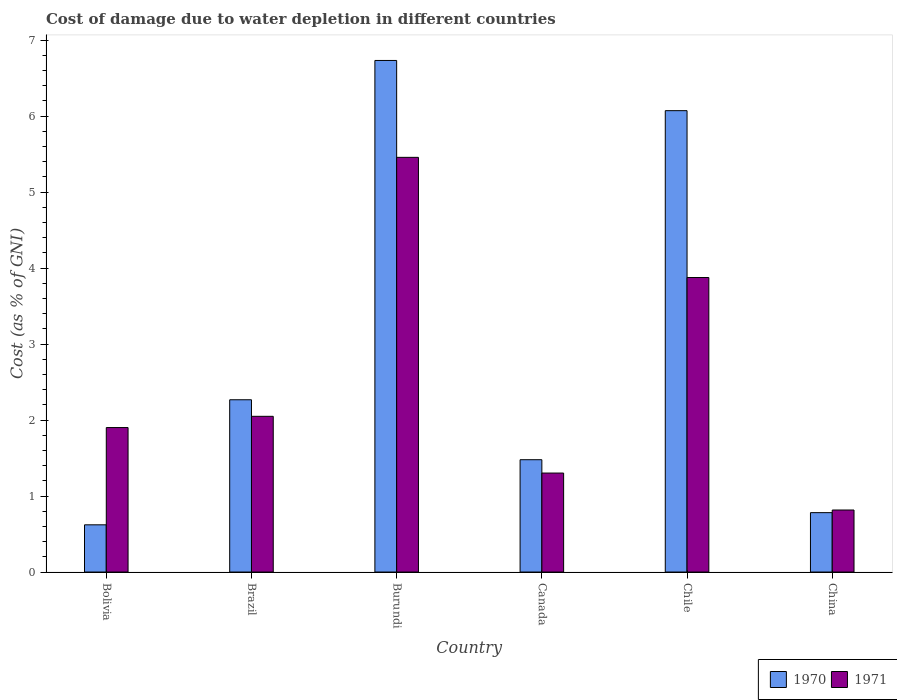How many different coloured bars are there?
Give a very brief answer. 2. How many groups of bars are there?
Provide a short and direct response. 6. Are the number of bars on each tick of the X-axis equal?
Offer a terse response. Yes. How many bars are there on the 4th tick from the left?
Give a very brief answer. 2. How many bars are there on the 1st tick from the right?
Keep it short and to the point. 2. What is the cost of damage caused due to water depletion in 1970 in Bolivia?
Provide a succinct answer. 0.62. Across all countries, what is the maximum cost of damage caused due to water depletion in 1971?
Offer a very short reply. 5.46. Across all countries, what is the minimum cost of damage caused due to water depletion in 1970?
Keep it short and to the point. 0.62. In which country was the cost of damage caused due to water depletion in 1970 maximum?
Your answer should be very brief. Burundi. What is the total cost of damage caused due to water depletion in 1971 in the graph?
Provide a short and direct response. 15.4. What is the difference between the cost of damage caused due to water depletion in 1971 in Bolivia and that in Chile?
Your answer should be compact. -1.97. What is the difference between the cost of damage caused due to water depletion in 1971 in Bolivia and the cost of damage caused due to water depletion in 1970 in Brazil?
Offer a very short reply. -0.37. What is the average cost of damage caused due to water depletion in 1970 per country?
Provide a short and direct response. 2.99. What is the difference between the cost of damage caused due to water depletion of/in 1970 and cost of damage caused due to water depletion of/in 1971 in Chile?
Offer a very short reply. 2.2. In how many countries, is the cost of damage caused due to water depletion in 1970 greater than 4.6 %?
Your response must be concise. 2. What is the ratio of the cost of damage caused due to water depletion in 1971 in Burundi to that in Chile?
Make the answer very short. 1.41. Is the difference between the cost of damage caused due to water depletion in 1970 in Bolivia and Canada greater than the difference between the cost of damage caused due to water depletion in 1971 in Bolivia and Canada?
Provide a succinct answer. No. What is the difference between the highest and the second highest cost of damage caused due to water depletion in 1971?
Ensure brevity in your answer.  -1.83. What is the difference between the highest and the lowest cost of damage caused due to water depletion in 1970?
Provide a short and direct response. 6.11. What does the 2nd bar from the left in China represents?
Give a very brief answer. 1971. What does the 2nd bar from the right in Burundi represents?
Give a very brief answer. 1970. How many bars are there?
Keep it short and to the point. 12. How many countries are there in the graph?
Make the answer very short. 6. Are the values on the major ticks of Y-axis written in scientific E-notation?
Your response must be concise. No. Does the graph contain any zero values?
Offer a terse response. No. Does the graph contain grids?
Offer a terse response. No. How are the legend labels stacked?
Provide a succinct answer. Horizontal. What is the title of the graph?
Ensure brevity in your answer.  Cost of damage due to water depletion in different countries. Does "2009" appear as one of the legend labels in the graph?
Your response must be concise. No. What is the label or title of the X-axis?
Offer a terse response. Country. What is the label or title of the Y-axis?
Offer a very short reply. Cost (as % of GNI). What is the Cost (as % of GNI) in 1970 in Bolivia?
Keep it short and to the point. 0.62. What is the Cost (as % of GNI) in 1971 in Bolivia?
Make the answer very short. 1.9. What is the Cost (as % of GNI) in 1970 in Brazil?
Your response must be concise. 2.27. What is the Cost (as % of GNI) in 1971 in Brazil?
Provide a succinct answer. 2.05. What is the Cost (as % of GNI) in 1970 in Burundi?
Your answer should be very brief. 6.73. What is the Cost (as % of GNI) of 1971 in Burundi?
Offer a very short reply. 5.46. What is the Cost (as % of GNI) in 1970 in Canada?
Your answer should be very brief. 1.48. What is the Cost (as % of GNI) in 1971 in Canada?
Make the answer very short. 1.3. What is the Cost (as % of GNI) in 1970 in Chile?
Keep it short and to the point. 6.07. What is the Cost (as % of GNI) of 1971 in Chile?
Your response must be concise. 3.88. What is the Cost (as % of GNI) of 1970 in China?
Give a very brief answer. 0.78. What is the Cost (as % of GNI) in 1971 in China?
Provide a succinct answer. 0.82. Across all countries, what is the maximum Cost (as % of GNI) in 1970?
Give a very brief answer. 6.73. Across all countries, what is the maximum Cost (as % of GNI) of 1971?
Your response must be concise. 5.46. Across all countries, what is the minimum Cost (as % of GNI) of 1970?
Offer a terse response. 0.62. Across all countries, what is the minimum Cost (as % of GNI) of 1971?
Give a very brief answer. 0.82. What is the total Cost (as % of GNI) of 1970 in the graph?
Give a very brief answer. 17.95. What is the total Cost (as % of GNI) in 1971 in the graph?
Give a very brief answer. 15.4. What is the difference between the Cost (as % of GNI) in 1970 in Bolivia and that in Brazil?
Make the answer very short. -1.65. What is the difference between the Cost (as % of GNI) of 1971 in Bolivia and that in Brazil?
Provide a short and direct response. -0.15. What is the difference between the Cost (as % of GNI) in 1970 in Bolivia and that in Burundi?
Ensure brevity in your answer.  -6.11. What is the difference between the Cost (as % of GNI) in 1971 in Bolivia and that in Burundi?
Offer a terse response. -3.56. What is the difference between the Cost (as % of GNI) of 1970 in Bolivia and that in Canada?
Make the answer very short. -0.86. What is the difference between the Cost (as % of GNI) in 1971 in Bolivia and that in Canada?
Your response must be concise. 0.6. What is the difference between the Cost (as % of GNI) in 1970 in Bolivia and that in Chile?
Provide a succinct answer. -5.45. What is the difference between the Cost (as % of GNI) in 1971 in Bolivia and that in Chile?
Offer a terse response. -1.97. What is the difference between the Cost (as % of GNI) of 1970 in Bolivia and that in China?
Provide a succinct answer. -0.16. What is the difference between the Cost (as % of GNI) of 1971 in Bolivia and that in China?
Your response must be concise. 1.09. What is the difference between the Cost (as % of GNI) in 1970 in Brazil and that in Burundi?
Ensure brevity in your answer.  -4.47. What is the difference between the Cost (as % of GNI) of 1971 in Brazil and that in Burundi?
Give a very brief answer. -3.41. What is the difference between the Cost (as % of GNI) in 1970 in Brazil and that in Canada?
Make the answer very short. 0.79. What is the difference between the Cost (as % of GNI) of 1971 in Brazil and that in Canada?
Ensure brevity in your answer.  0.75. What is the difference between the Cost (as % of GNI) of 1970 in Brazil and that in Chile?
Ensure brevity in your answer.  -3.8. What is the difference between the Cost (as % of GNI) in 1971 in Brazil and that in Chile?
Give a very brief answer. -1.83. What is the difference between the Cost (as % of GNI) of 1970 in Brazil and that in China?
Offer a very short reply. 1.49. What is the difference between the Cost (as % of GNI) of 1971 in Brazil and that in China?
Ensure brevity in your answer.  1.23. What is the difference between the Cost (as % of GNI) of 1970 in Burundi and that in Canada?
Keep it short and to the point. 5.25. What is the difference between the Cost (as % of GNI) in 1971 in Burundi and that in Canada?
Ensure brevity in your answer.  4.15. What is the difference between the Cost (as % of GNI) in 1970 in Burundi and that in Chile?
Offer a very short reply. 0.66. What is the difference between the Cost (as % of GNI) in 1971 in Burundi and that in Chile?
Your answer should be compact. 1.58. What is the difference between the Cost (as % of GNI) of 1970 in Burundi and that in China?
Make the answer very short. 5.95. What is the difference between the Cost (as % of GNI) in 1971 in Burundi and that in China?
Provide a succinct answer. 4.64. What is the difference between the Cost (as % of GNI) of 1970 in Canada and that in Chile?
Offer a terse response. -4.59. What is the difference between the Cost (as % of GNI) in 1971 in Canada and that in Chile?
Keep it short and to the point. -2.57. What is the difference between the Cost (as % of GNI) of 1970 in Canada and that in China?
Offer a very short reply. 0.7. What is the difference between the Cost (as % of GNI) in 1971 in Canada and that in China?
Provide a succinct answer. 0.49. What is the difference between the Cost (as % of GNI) of 1970 in Chile and that in China?
Keep it short and to the point. 5.29. What is the difference between the Cost (as % of GNI) in 1971 in Chile and that in China?
Your response must be concise. 3.06. What is the difference between the Cost (as % of GNI) in 1970 in Bolivia and the Cost (as % of GNI) in 1971 in Brazil?
Keep it short and to the point. -1.43. What is the difference between the Cost (as % of GNI) of 1970 in Bolivia and the Cost (as % of GNI) of 1971 in Burundi?
Provide a succinct answer. -4.84. What is the difference between the Cost (as % of GNI) in 1970 in Bolivia and the Cost (as % of GNI) in 1971 in Canada?
Your response must be concise. -0.68. What is the difference between the Cost (as % of GNI) of 1970 in Bolivia and the Cost (as % of GNI) of 1971 in Chile?
Your answer should be compact. -3.25. What is the difference between the Cost (as % of GNI) in 1970 in Bolivia and the Cost (as % of GNI) in 1971 in China?
Your answer should be very brief. -0.19. What is the difference between the Cost (as % of GNI) of 1970 in Brazil and the Cost (as % of GNI) of 1971 in Burundi?
Provide a short and direct response. -3.19. What is the difference between the Cost (as % of GNI) in 1970 in Brazil and the Cost (as % of GNI) in 1971 in Canada?
Ensure brevity in your answer.  0.96. What is the difference between the Cost (as % of GNI) of 1970 in Brazil and the Cost (as % of GNI) of 1971 in Chile?
Your answer should be very brief. -1.61. What is the difference between the Cost (as % of GNI) in 1970 in Brazil and the Cost (as % of GNI) in 1971 in China?
Provide a succinct answer. 1.45. What is the difference between the Cost (as % of GNI) of 1970 in Burundi and the Cost (as % of GNI) of 1971 in Canada?
Give a very brief answer. 5.43. What is the difference between the Cost (as % of GNI) of 1970 in Burundi and the Cost (as % of GNI) of 1971 in Chile?
Make the answer very short. 2.86. What is the difference between the Cost (as % of GNI) in 1970 in Burundi and the Cost (as % of GNI) in 1971 in China?
Your answer should be very brief. 5.92. What is the difference between the Cost (as % of GNI) of 1970 in Canada and the Cost (as % of GNI) of 1971 in Chile?
Your answer should be very brief. -2.4. What is the difference between the Cost (as % of GNI) of 1970 in Canada and the Cost (as % of GNI) of 1971 in China?
Your answer should be compact. 0.66. What is the difference between the Cost (as % of GNI) of 1970 in Chile and the Cost (as % of GNI) of 1971 in China?
Your answer should be very brief. 5.26. What is the average Cost (as % of GNI) in 1970 per country?
Keep it short and to the point. 2.99. What is the average Cost (as % of GNI) in 1971 per country?
Your answer should be very brief. 2.57. What is the difference between the Cost (as % of GNI) in 1970 and Cost (as % of GNI) in 1971 in Bolivia?
Your response must be concise. -1.28. What is the difference between the Cost (as % of GNI) in 1970 and Cost (as % of GNI) in 1971 in Brazil?
Your response must be concise. 0.22. What is the difference between the Cost (as % of GNI) in 1970 and Cost (as % of GNI) in 1971 in Burundi?
Ensure brevity in your answer.  1.28. What is the difference between the Cost (as % of GNI) of 1970 and Cost (as % of GNI) of 1971 in Canada?
Keep it short and to the point. 0.18. What is the difference between the Cost (as % of GNI) of 1970 and Cost (as % of GNI) of 1971 in Chile?
Your response must be concise. 2.2. What is the difference between the Cost (as % of GNI) of 1970 and Cost (as % of GNI) of 1971 in China?
Your answer should be compact. -0.03. What is the ratio of the Cost (as % of GNI) in 1970 in Bolivia to that in Brazil?
Give a very brief answer. 0.27. What is the ratio of the Cost (as % of GNI) of 1971 in Bolivia to that in Brazil?
Make the answer very short. 0.93. What is the ratio of the Cost (as % of GNI) of 1970 in Bolivia to that in Burundi?
Keep it short and to the point. 0.09. What is the ratio of the Cost (as % of GNI) in 1971 in Bolivia to that in Burundi?
Your answer should be very brief. 0.35. What is the ratio of the Cost (as % of GNI) in 1970 in Bolivia to that in Canada?
Make the answer very short. 0.42. What is the ratio of the Cost (as % of GNI) of 1971 in Bolivia to that in Canada?
Provide a succinct answer. 1.46. What is the ratio of the Cost (as % of GNI) of 1970 in Bolivia to that in Chile?
Offer a terse response. 0.1. What is the ratio of the Cost (as % of GNI) in 1971 in Bolivia to that in Chile?
Ensure brevity in your answer.  0.49. What is the ratio of the Cost (as % of GNI) in 1970 in Bolivia to that in China?
Keep it short and to the point. 0.8. What is the ratio of the Cost (as % of GNI) of 1971 in Bolivia to that in China?
Provide a succinct answer. 2.33. What is the ratio of the Cost (as % of GNI) of 1970 in Brazil to that in Burundi?
Make the answer very short. 0.34. What is the ratio of the Cost (as % of GNI) of 1971 in Brazil to that in Burundi?
Keep it short and to the point. 0.38. What is the ratio of the Cost (as % of GNI) in 1970 in Brazil to that in Canada?
Your response must be concise. 1.53. What is the ratio of the Cost (as % of GNI) in 1971 in Brazil to that in Canada?
Keep it short and to the point. 1.57. What is the ratio of the Cost (as % of GNI) of 1970 in Brazil to that in Chile?
Keep it short and to the point. 0.37. What is the ratio of the Cost (as % of GNI) of 1971 in Brazil to that in Chile?
Keep it short and to the point. 0.53. What is the ratio of the Cost (as % of GNI) in 1970 in Brazil to that in China?
Ensure brevity in your answer.  2.9. What is the ratio of the Cost (as % of GNI) of 1971 in Brazil to that in China?
Offer a very short reply. 2.51. What is the ratio of the Cost (as % of GNI) of 1970 in Burundi to that in Canada?
Provide a short and direct response. 4.55. What is the ratio of the Cost (as % of GNI) in 1971 in Burundi to that in Canada?
Offer a very short reply. 4.19. What is the ratio of the Cost (as % of GNI) in 1970 in Burundi to that in Chile?
Provide a succinct answer. 1.11. What is the ratio of the Cost (as % of GNI) of 1971 in Burundi to that in Chile?
Ensure brevity in your answer.  1.41. What is the ratio of the Cost (as % of GNI) in 1970 in Burundi to that in China?
Provide a succinct answer. 8.61. What is the ratio of the Cost (as % of GNI) in 1971 in Burundi to that in China?
Your answer should be very brief. 6.69. What is the ratio of the Cost (as % of GNI) in 1970 in Canada to that in Chile?
Provide a short and direct response. 0.24. What is the ratio of the Cost (as % of GNI) of 1971 in Canada to that in Chile?
Your response must be concise. 0.34. What is the ratio of the Cost (as % of GNI) in 1970 in Canada to that in China?
Give a very brief answer. 1.89. What is the ratio of the Cost (as % of GNI) in 1971 in Canada to that in China?
Make the answer very short. 1.6. What is the ratio of the Cost (as % of GNI) in 1970 in Chile to that in China?
Offer a terse response. 7.77. What is the ratio of the Cost (as % of GNI) in 1971 in Chile to that in China?
Provide a short and direct response. 4.75. What is the difference between the highest and the second highest Cost (as % of GNI) in 1970?
Provide a short and direct response. 0.66. What is the difference between the highest and the second highest Cost (as % of GNI) in 1971?
Offer a very short reply. 1.58. What is the difference between the highest and the lowest Cost (as % of GNI) of 1970?
Keep it short and to the point. 6.11. What is the difference between the highest and the lowest Cost (as % of GNI) in 1971?
Make the answer very short. 4.64. 